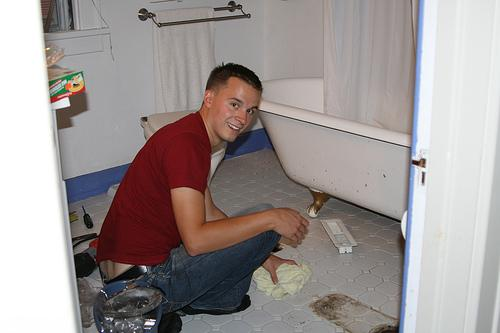Please provide details about the hair and overall appearance of the man in the picture. The man has short brown hair, a red shirt, blue jeans, and a black leather belt. Explain what the man is holding and what color the item is in the image? The man is holding a yellow towel in his hand. What type of bathtub is seen in the image and describe its appearance. There is a white clawfoot bathtub in the image with a white shower curtain. What emotion or sentiment would you associate with the scene in this image? The image conveys a sense of diligence or responsibility as the man is working to fix or clean the bathroom. Explain the context of the image in terms of the activities depicted and the setting. The image shows a man working on fixing or cleaning a bathroom, with various bathroom elements like a bathtub, shower curtain, and towels visible. Can you tell me if there's any anomaly or irregularity that can be seen in the image? There is dirt on the white tile bathroom floor, which might be considered an anomaly. What color is the shirt the young man is wearing and what is he doing in the image? The young man is wearing a red shirt and he is fixing the bathroom. Identify the type of animal seen on the floor where people normally step on. There is no animal on the bathroom floor in the image. What's the main focus of the image and describe what is happening in the scene? The main focus is a man fixing the bathroom, and he is squatting while holding a yellow towel. Please mention any items that are lying on the bathroom floor in this image. There is a screwdriver and dirt on the white tile bathroom floor. Can you spot a purple towel hanging on the wall behind the man? A purple towel is hanging on the wall to the right of the man. Is the dog with a blue collar lying down on the bathroom floor? There's a dog in the bathroom, observing the man while he works. Can you find a red toolbox sitting on the bathroom floor near the screwdriver? There is a red toolbox full of tools on the floor, ready for the man to use. Is there a toothbrush and a tube of toothpaste on the counter by the sink? There is a toothbrush and toothpaste placed on the counter next to the sink. Do you see the woman wearing a green apron standing by the bathtub? A woman wearing a green apron is assisting the man by handing him tools. Can you find the pink rubber duck floating in the bathtub? There is a pink rubber duck, placed right in the center of the tub. 